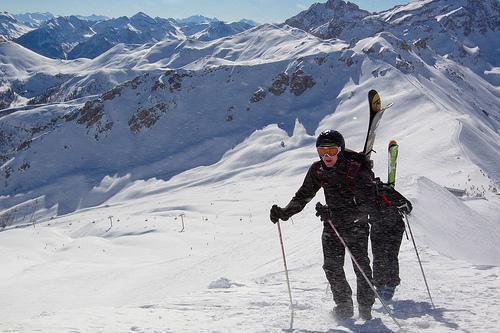How many people are in this picture?
Give a very brief answer. 2. 